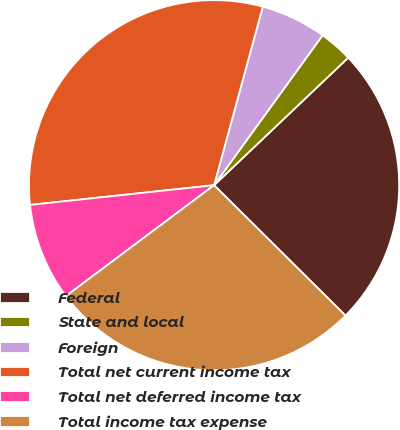Convert chart. <chart><loc_0><loc_0><loc_500><loc_500><pie_chart><fcel>Federal<fcel>State and local<fcel>Foreign<fcel>Total net current income tax<fcel>Total net deferred income tax<fcel>Total income tax expense<nl><fcel>24.53%<fcel>2.93%<fcel>5.73%<fcel>30.93%<fcel>8.53%<fcel>27.33%<nl></chart> 